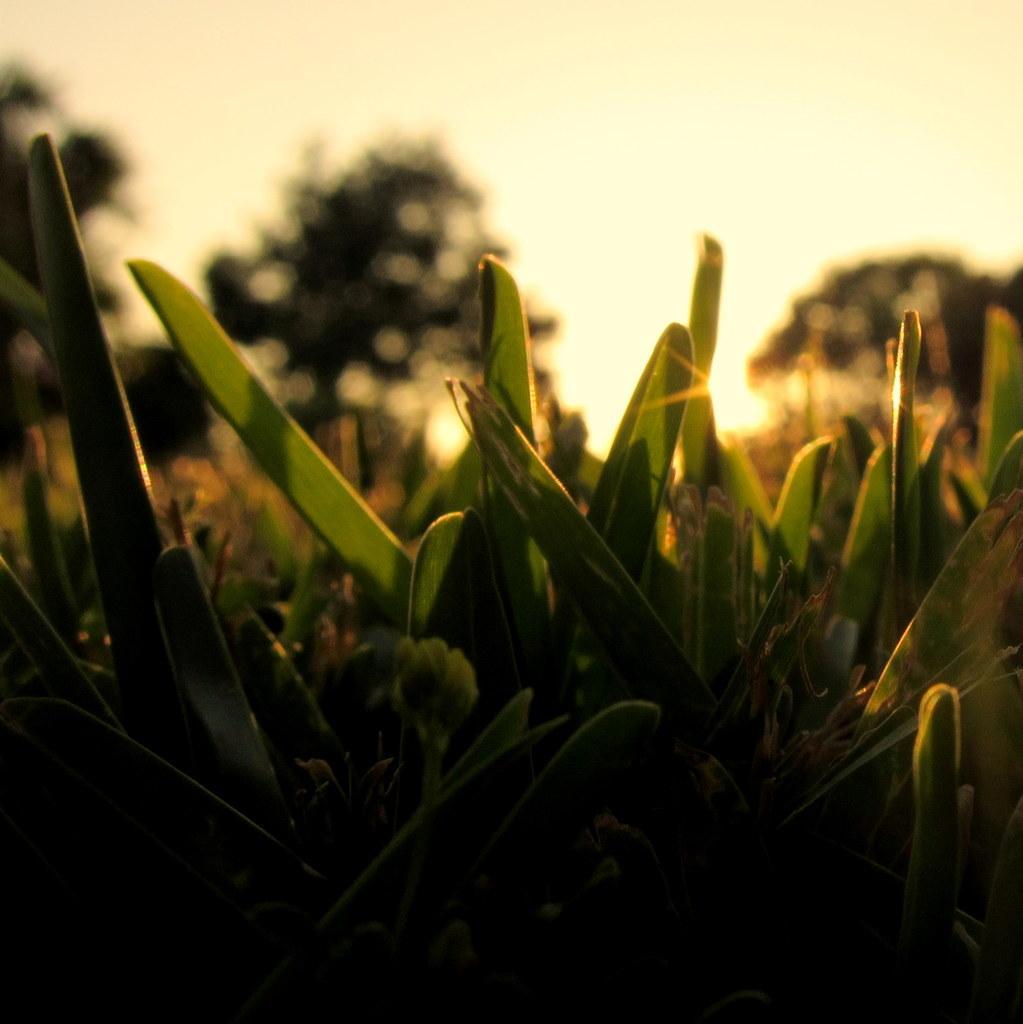Please provide a concise description of this image. In this image there are plants, trees and the sky. 